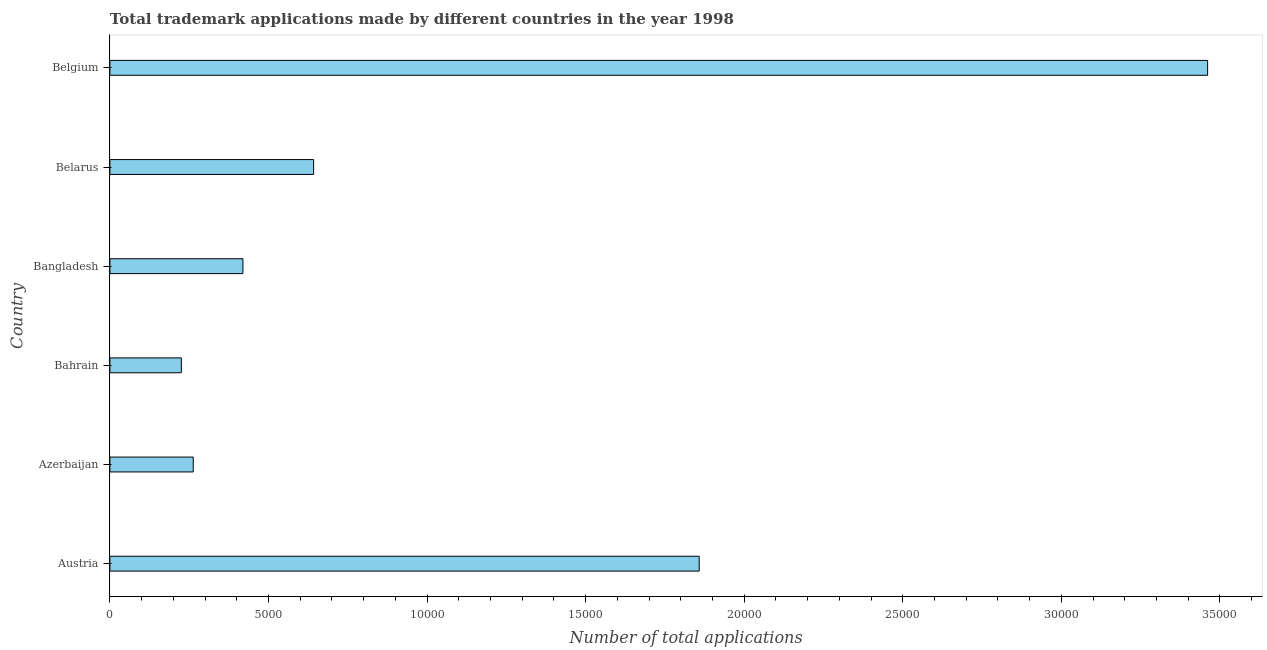Does the graph contain any zero values?
Offer a terse response. No. What is the title of the graph?
Offer a very short reply. Total trademark applications made by different countries in the year 1998. What is the label or title of the X-axis?
Your answer should be very brief. Number of total applications. What is the label or title of the Y-axis?
Keep it short and to the point. Country. What is the number of trademark applications in Austria?
Offer a very short reply. 1.86e+04. Across all countries, what is the maximum number of trademark applications?
Your response must be concise. 3.46e+04. Across all countries, what is the minimum number of trademark applications?
Provide a short and direct response. 2253. In which country was the number of trademark applications minimum?
Offer a terse response. Bahrain. What is the sum of the number of trademark applications?
Ensure brevity in your answer.  6.87e+04. What is the difference between the number of trademark applications in Bahrain and Belarus?
Your answer should be compact. -4171. What is the average number of trademark applications per country?
Your answer should be very brief. 1.14e+04. What is the median number of trademark applications?
Give a very brief answer. 5309.5. In how many countries, is the number of trademark applications greater than 8000 ?
Your response must be concise. 2. What is the ratio of the number of trademark applications in Austria to that in Belgium?
Make the answer very short. 0.54. Is the difference between the number of trademark applications in Bahrain and Bangladesh greater than the difference between any two countries?
Keep it short and to the point. No. What is the difference between the highest and the second highest number of trademark applications?
Keep it short and to the point. 1.60e+04. Is the sum of the number of trademark applications in Austria and Belarus greater than the maximum number of trademark applications across all countries?
Give a very brief answer. No. What is the difference between the highest and the lowest number of trademark applications?
Provide a short and direct response. 3.24e+04. In how many countries, is the number of trademark applications greater than the average number of trademark applications taken over all countries?
Provide a succinct answer. 2. Are all the bars in the graph horizontal?
Ensure brevity in your answer.  Yes. What is the difference between two consecutive major ticks on the X-axis?
Ensure brevity in your answer.  5000. Are the values on the major ticks of X-axis written in scientific E-notation?
Make the answer very short. No. What is the Number of total applications in Austria?
Ensure brevity in your answer.  1.86e+04. What is the Number of total applications of Azerbaijan?
Keep it short and to the point. 2628. What is the Number of total applications in Bahrain?
Your answer should be compact. 2253. What is the Number of total applications of Bangladesh?
Your answer should be very brief. 4195. What is the Number of total applications of Belarus?
Offer a very short reply. 6424. What is the Number of total applications of Belgium?
Give a very brief answer. 3.46e+04. What is the difference between the Number of total applications in Austria and Azerbaijan?
Make the answer very short. 1.60e+04. What is the difference between the Number of total applications in Austria and Bahrain?
Your answer should be compact. 1.63e+04. What is the difference between the Number of total applications in Austria and Bangladesh?
Your answer should be compact. 1.44e+04. What is the difference between the Number of total applications in Austria and Belarus?
Provide a short and direct response. 1.22e+04. What is the difference between the Number of total applications in Austria and Belgium?
Provide a succinct answer. -1.60e+04. What is the difference between the Number of total applications in Azerbaijan and Bahrain?
Your answer should be compact. 375. What is the difference between the Number of total applications in Azerbaijan and Bangladesh?
Your answer should be compact. -1567. What is the difference between the Number of total applications in Azerbaijan and Belarus?
Give a very brief answer. -3796. What is the difference between the Number of total applications in Azerbaijan and Belgium?
Offer a very short reply. -3.20e+04. What is the difference between the Number of total applications in Bahrain and Bangladesh?
Your answer should be compact. -1942. What is the difference between the Number of total applications in Bahrain and Belarus?
Ensure brevity in your answer.  -4171. What is the difference between the Number of total applications in Bahrain and Belgium?
Your answer should be very brief. -3.24e+04. What is the difference between the Number of total applications in Bangladesh and Belarus?
Make the answer very short. -2229. What is the difference between the Number of total applications in Bangladesh and Belgium?
Provide a short and direct response. -3.04e+04. What is the difference between the Number of total applications in Belarus and Belgium?
Offer a terse response. -2.82e+04. What is the ratio of the Number of total applications in Austria to that in Azerbaijan?
Your answer should be very brief. 7.07. What is the ratio of the Number of total applications in Austria to that in Bahrain?
Your answer should be compact. 8.25. What is the ratio of the Number of total applications in Austria to that in Bangladesh?
Ensure brevity in your answer.  4.43. What is the ratio of the Number of total applications in Austria to that in Belarus?
Offer a terse response. 2.89. What is the ratio of the Number of total applications in Austria to that in Belgium?
Make the answer very short. 0.54. What is the ratio of the Number of total applications in Azerbaijan to that in Bahrain?
Provide a short and direct response. 1.17. What is the ratio of the Number of total applications in Azerbaijan to that in Bangladesh?
Make the answer very short. 0.63. What is the ratio of the Number of total applications in Azerbaijan to that in Belarus?
Make the answer very short. 0.41. What is the ratio of the Number of total applications in Azerbaijan to that in Belgium?
Your answer should be compact. 0.08. What is the ratio of the Number of total applications in Bahrain to that in Bangladesh?
Your answer should be very brief. 0.54. What is the ratio of the Number of total applications in Bahrain to that in Belarus?
Provide a succinct answer. 0.35. What is the ratio of the Number of total applications in Bahrain to that in Belgium?
Ensure brevity in your answer.  0.07. What is the ratio of the Number of total applications in Bangladesh to that in Belarus?
Provide a short and direct response. 0.65. What is the ratio of the Number of total applications in Bangladesh to that in Belgium?
Give a very brief answer. 0.12. What is the ratio of the Number of total applications in Belarus to that in Belgium?
Keep it short and to the point. 0.19. 